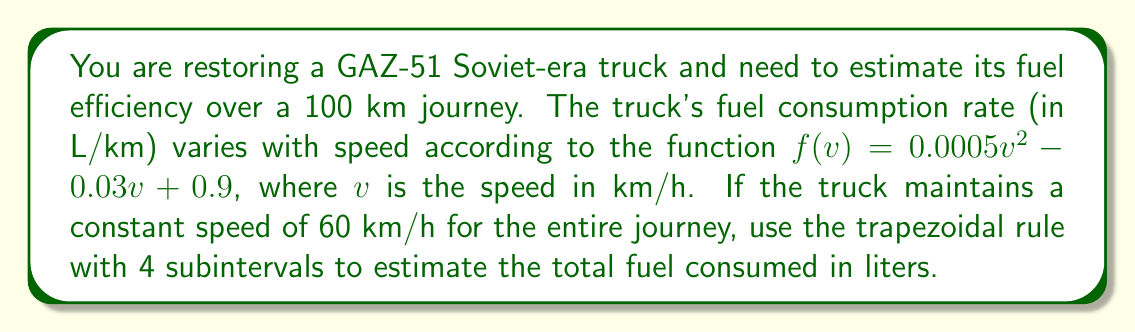Provide a solution to this math problem. 1) First, we need to set up the integral. The fuel consumption over the journey is:

   $$\int_0^{100} f(v) dv$$

   where $v$ is constant at 60 km/h.

2) Substituting $v=60$ into $f(v)$:
   
   $f(60) = 0.0005(60)^2 - 0.03(60) + 0.9 = 1.8 - 1.8 + 0.9 = 0.9$ L/km

3) Now our integral simplifies to:

   $$\int_0^{100} 0.9 dv = 0.9 \times 100 = 90$$ liters

4) To apply the trapezoidal rule with 4 subintervals, we divide the interval [0, 100] into 4 equal parts:

   $\Delta x = \frac{100 - 0}{4} = 25$ km

5) The trapezoidal rule formula is:

   $$\int_a^b f(x)dx \approx \frac{\Delta x}{2}[f(x_0) + 2f(x_1) + 2f(x_2) + 2f(x_3) + f(x_4)]$$

6) Substituting our values:

   $$90 \approx \frac{25}{2}[0.9 + 2(0.9) + 2(0.9) + 2(0.9) + 0.9]$$
   $$= \frac{25}{2}[0.9 + 7.2]$$
   $$= \frac{25}{2}(8.1)$$
   $$= 101.25$$ liters

7) Therefore, the trapezoidal rule estimate for fuel consumed is 101.25 liters.
Answer: 101.25 liters 